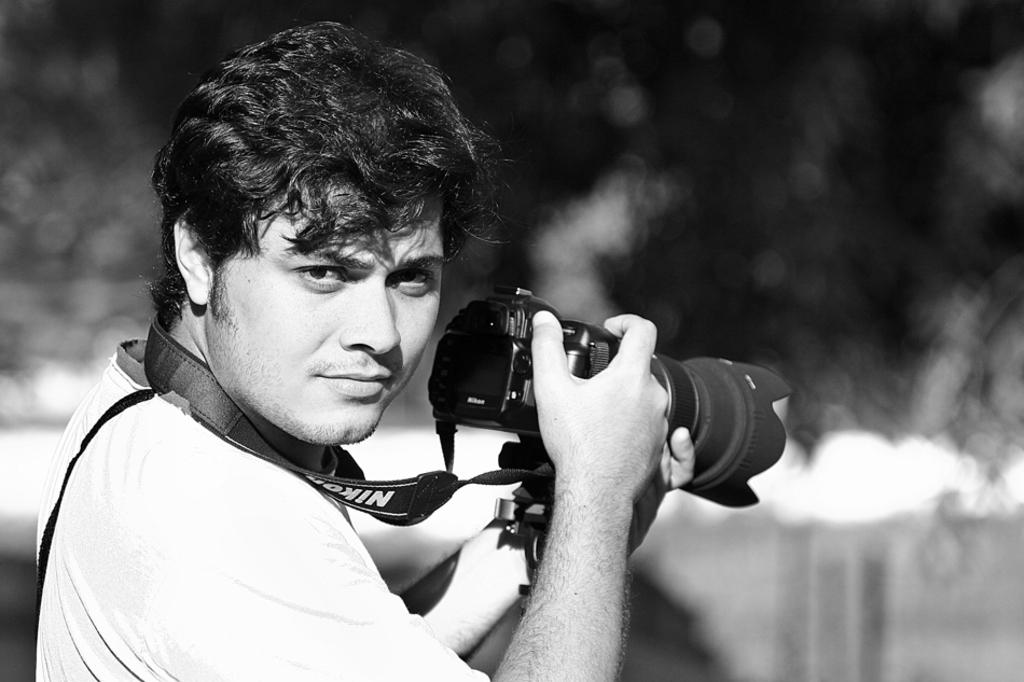What is the main subject of the image? There is a man in the image. What is the man holding in his hand? The man is holding a camera in his hand. What is the color scheme of the image? The image is black and white. What month is it in the image? The month cannot be determined from the image, as it is in black and white and does not contain any contextual clues about the time of year. 